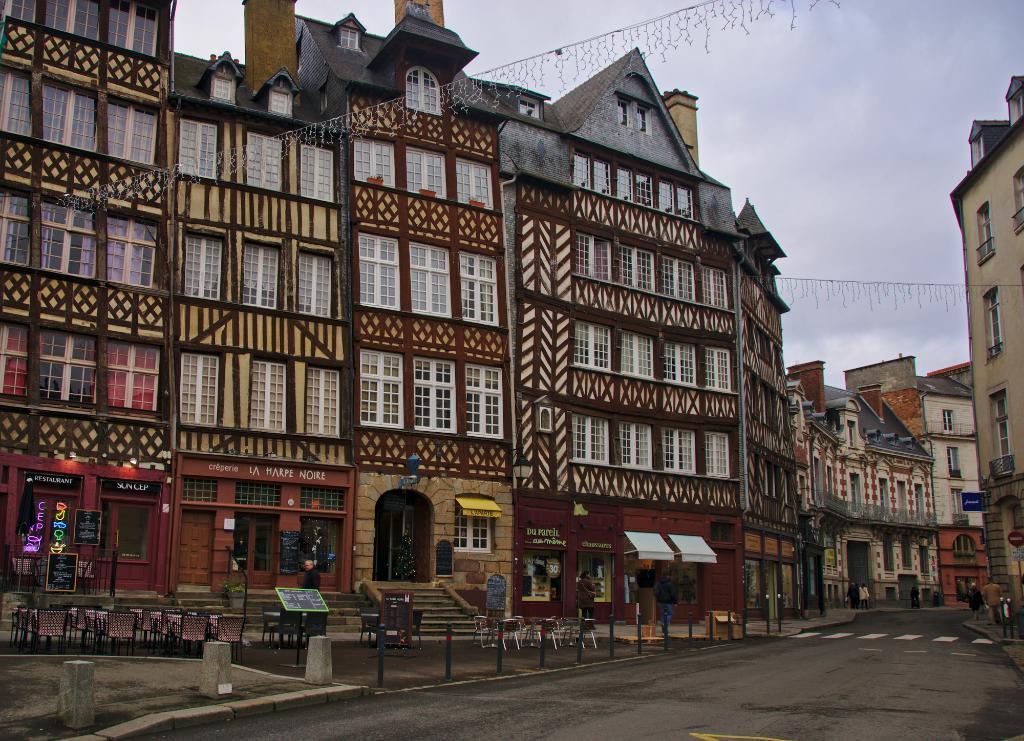Could you give a brief overview of what you see in this image? In this image there are buildings. At the bottom there is a road and we can see chairs and stands. We can see a road. In the background there is sky. 